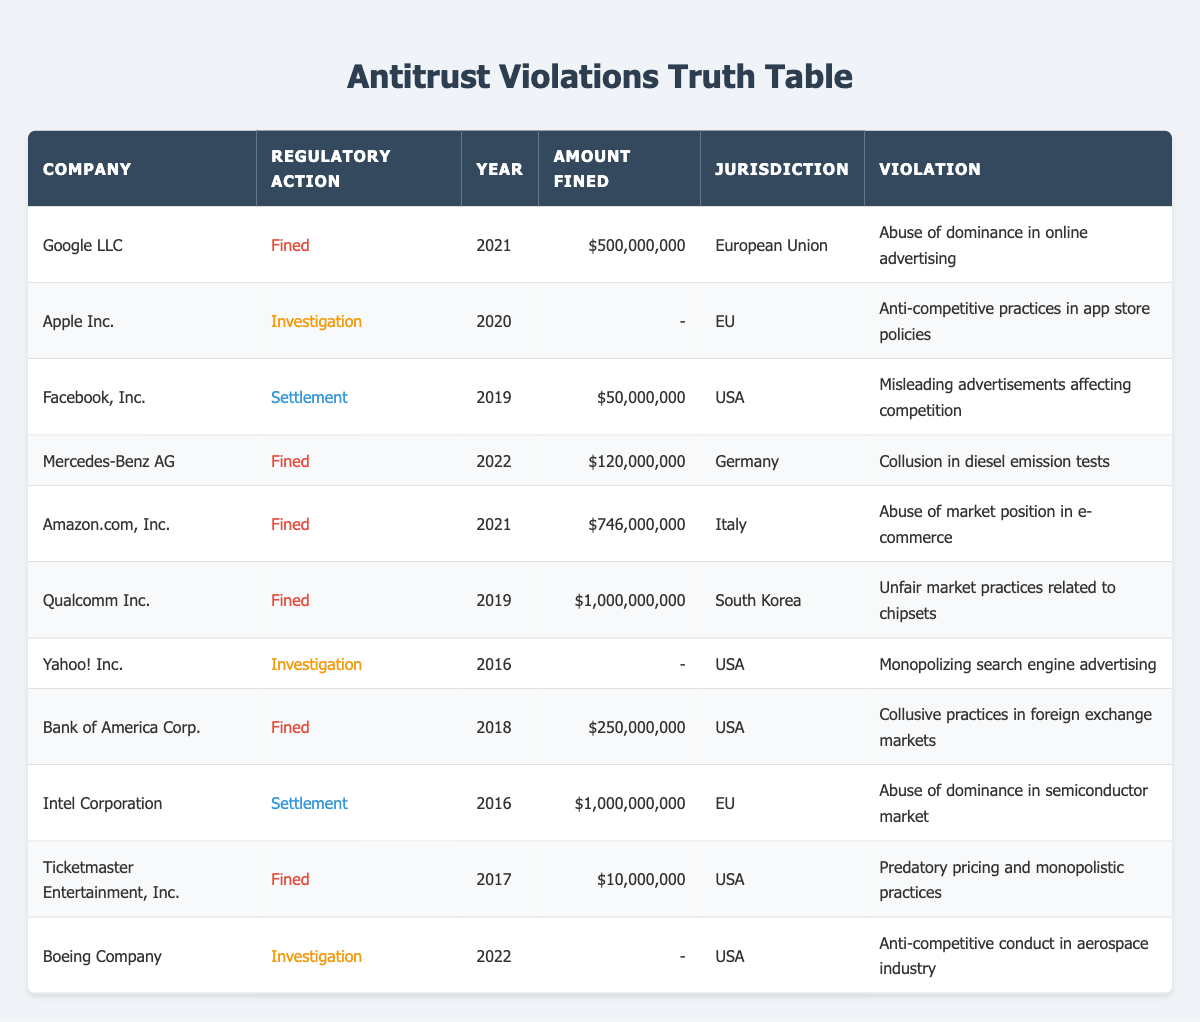What was the total amount fined to Google LLC? The table shows that Google LLC was fined $500,000,000 in 2021 for abusing dominance in online advertising. Therefore, the total amount fined to Google LLC is $500,000,000.
Answer: 500000000 How many companies were fined in the USA? By looking through the table, the companies that were fined in the USA are Facebook, Bank of America, and Ticketmaster. Counting these entries gives us 3 companies fined in the USA.
Answer: 3 What is the average amount fined across all companies? To find the average, sum up all the fines that have a value: $500,000,000 (Google) + $50,000,000 (Facebook) + $120,000,000 (Mercedes) + $746,000,000 (Amazon) + $1,000,000,000 (Qualcomm) + $250,000,000 (Bank of America) + $10,000,000 (Ticketmaster) = $2,676,000,000. There are 7 fines recorded, so the average is $2,676,000,000 / 7 = approximately $382,285,714.
Answer: 382285714 Was there any investigation against companies in the USA for antitrust violations? The table indicates that there were investigations against Yahoo! Inc. and Boeing Company in the USA. Therefore, the answer is yes, there were investigations.
Answer: Yes Which company faced the highest fine and how much was it? From reviewing the table, Qualcomm Inc. faced the highest fine of $1,000,000,000 in 2019 for unfair market practices related to chipsets. Therefore, the highest fine was $1,000,000,000 by Qualcomm Inc.
Answer: 1000000000 How many companies were investigated in the European Union? In the table, the companies investigated in the EU include Apple Inc. and Intel Corporation. Thus, there are 2 companies that were investigated in the European Union.
Answer: 2 Did Amazon.com, Inc. face any fines for antitrust violations? The table shows that Amazon.com, Inc. was fined $746,000,000 in 2021 for abuse of market position in e-commerce, which confirms that they indeed faced fines.
Answer: Yes What violations led to fines in the last decade? Upon reviewing the table, the violations leading to fines include abuse of dominance in online advertising, collusion in diesel emission tests, abuse of market position in e-commerce, unfair market practices related to chipsets, collusive practices in foreign exchange markets, and predatory pricing and monopolistic practices.
Answer: Multiple violations What was the total amount fined in the European Union? The total fines in the European Union include $500,000,000 by Google LLC (2021) and $1,000,000,000 by Intel Corporation (2016), totaling $1,500,000,000 for the EU.
Answer: 1500000000 